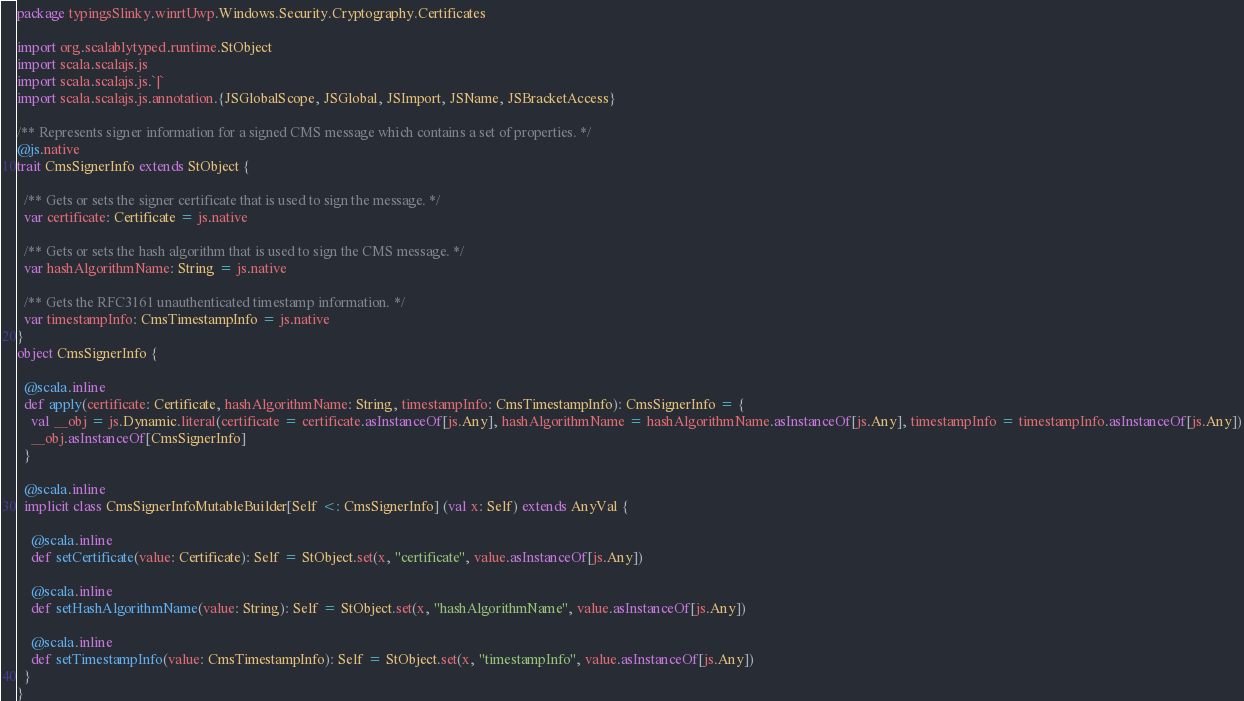Convert code to text. <code><loc_0><loc_0><loc_500><loc_500><_Scala_>package typingsSlinky.winrtUwp.Windows.Security.Cryptography.Certificates

import org.scalablytyped.runtime.StObject
import scala.scalajs.js
import scala.scalajs.js.`|`
import scala.scalajs.js.annotation.{JSGlobalScope, JSGlobal, JSImport, JSName, JSBracketAccess}

/** Represents signer information for a signed CMS message which contains a set of properties. */
@js.native
trait CmsSignerInfo extends StObject {
  
  /** Gets or sets the signer certificate that is used to sign the message. */
  var certificate: Certificate = js.native
  
  /** Gets or sets the hash algorithm that is used to sign the CMS message. */
  var hashAlgorithmName: String = js.native
  
  /** Gets the RFC3161 unauthenticated timestamp information. */
  var timestampInfo: CmsTimestampInfo = js.native
}
object CmsSignerInfo {
  
  @scala.inline
  def apply(certificate: Certificate, hashAlgorithmName: String, timestampInfo: CmsTimestampInfo): CmsSignerInfo = {
    val __obj = js.Dynamic.literal(certificate = certificate.asInstanceOf[js.Any], hashAlgorithmName = hashAlgorithmName.asInstanceOf[js.Any], timestampInfo = timestampInfo.asInstanceOf[js.Any])
    __obj.asInstanceOf[CmsSignerInfo]
  }
  
  @scala.inline
  implicit class CmsSignerInfoMutableBuilder[Self <: CmsSignerInfo] (val x: Self) extends AnyVal {
    
    @scala.inline
    def setCertificate(value: Certificate): Self = StObject.set(x, "certificate", value.asInstanceOf[js.Any])
    
    @scala.inline
    def setHashAlgorithmName(value: String): Self = StObject.set(x, "hashAlgorithmName", value.asInstanceOf[js.Any])
    
    @scala.inline
    def setTimestampInfo(value: CmsTimestampInfo): Self = StObject.set(x, "timestampInfo", value.asInstanceOf[js.Any])
  }
}
</code> 